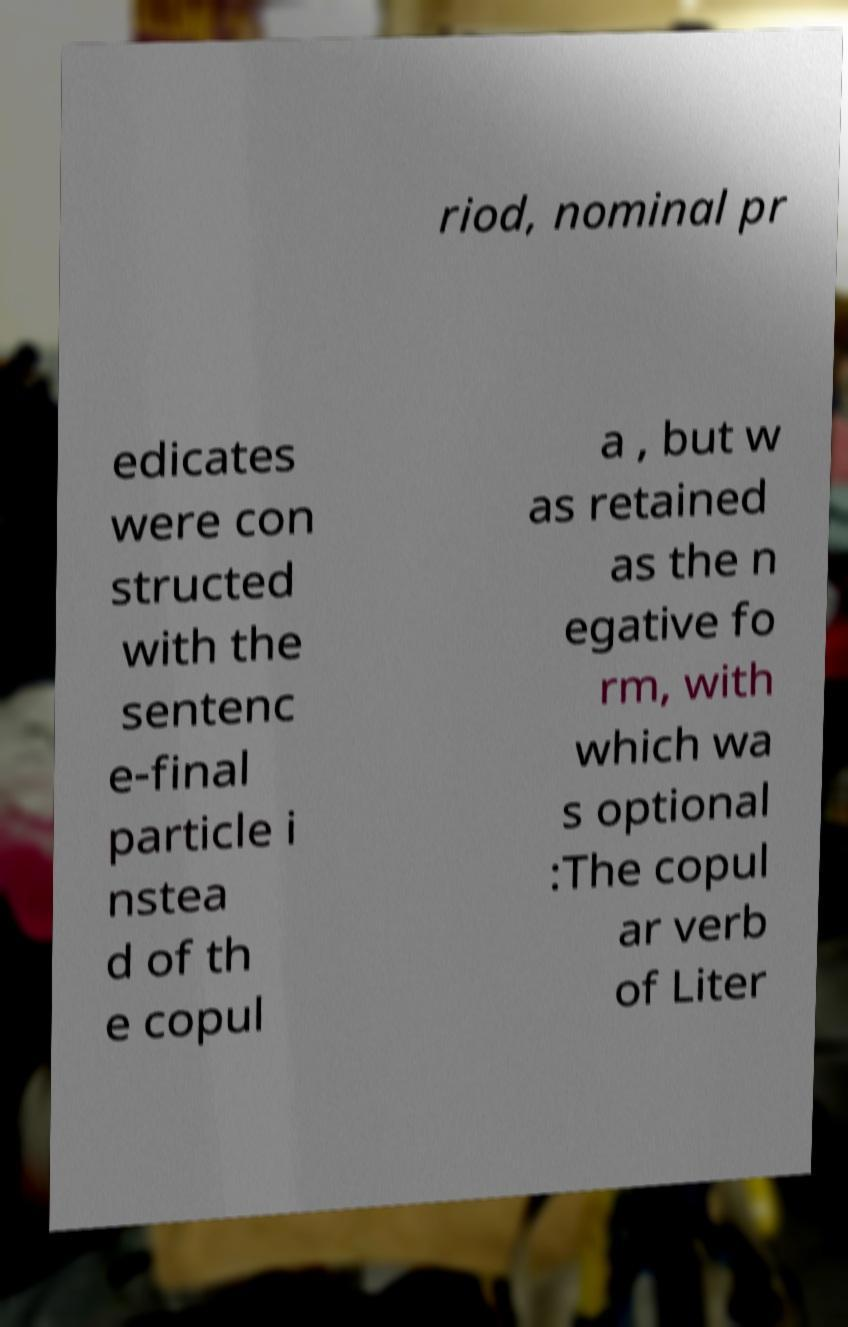For documentation purposes, I need the text within this image transcribed. Could you provide that? riod, nominal pr edicates were con structed with the sentenc e-final particle i nstea d of th e copul a , but w as retained as the n egative fo rm, with which wa s optional :The copul ar verb of Liter 